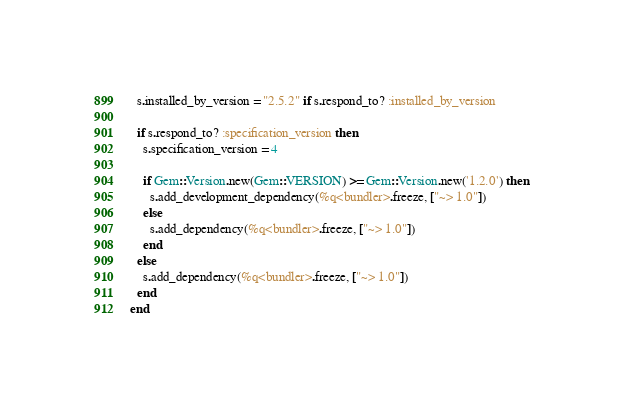<code> <loc_0><loc_0><loc_500><loc_500><_Ruby_>  s.installed_by_version = "2.5.2" if s.respond_to? :installed_by_version

  if s.respond_to? :specification_version then
    s.specification_version = 4

    if Gem::Version.new(Gem::VERSION) >= Gem::Version.new('1.2.0') then
      s.add_development_dependency(%q<bundler>.freeze, ["~> 1.0"])
    else
      s.add_dependency(%q<bundler>.freeze, ["~> 1.0"])
    end
  else
    s.add_dependency(%q<bundler>.freeze, ["~> 1.0"])
  end
end
</code> 